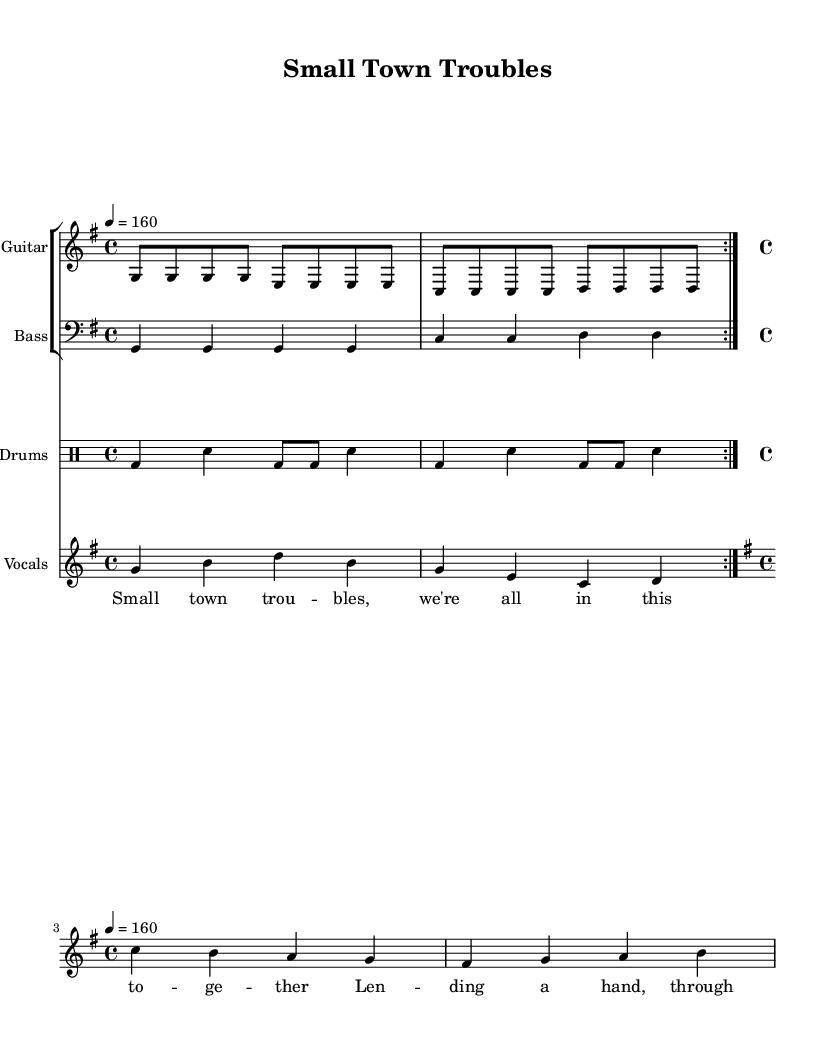what is the key signature of this music? The key signature is G major, as indicated by one sharp (F#) in the key signature section at the beginning of the score.
Answer: G major what is the time signature of this music? The time signature is 4/4, which allows for four beats in a measure, as shown at the start of the sheet music.
Answer: 4/4 what is the tempo marking of this song? The tempo marking indicates a speed of 160 beats per minute, as specified near the top of the score.
Answer: 160 how many sections are there in the repeated part? The repeated part consists of 2 sections, as denoted by the "repeat volta 2" marking for both the guitar and drums.
Answer: 2 what does the chorus lyrics emphasize about community? The chorus emphasizes lending a hand and support through challenges, highlighting togetherness and resilience, which is a common theme in pop punk focusing on close-knit communities.
Answer: Togetherness what is the form of the song based on the structure? The song follows a verse-chorus form, which is typical for punk songs, featuring verses and a distinct chorus that presents the main theme.
Answer: Verse-Chorus how does the use of the electric guitar influence the song's style? The electric guitar contributes to the energetic and rebellious sound characteristic of punk music, making the song feel more assertive and alive, which aligns with the themes explored in the lyrics.
Answer: Energetic 